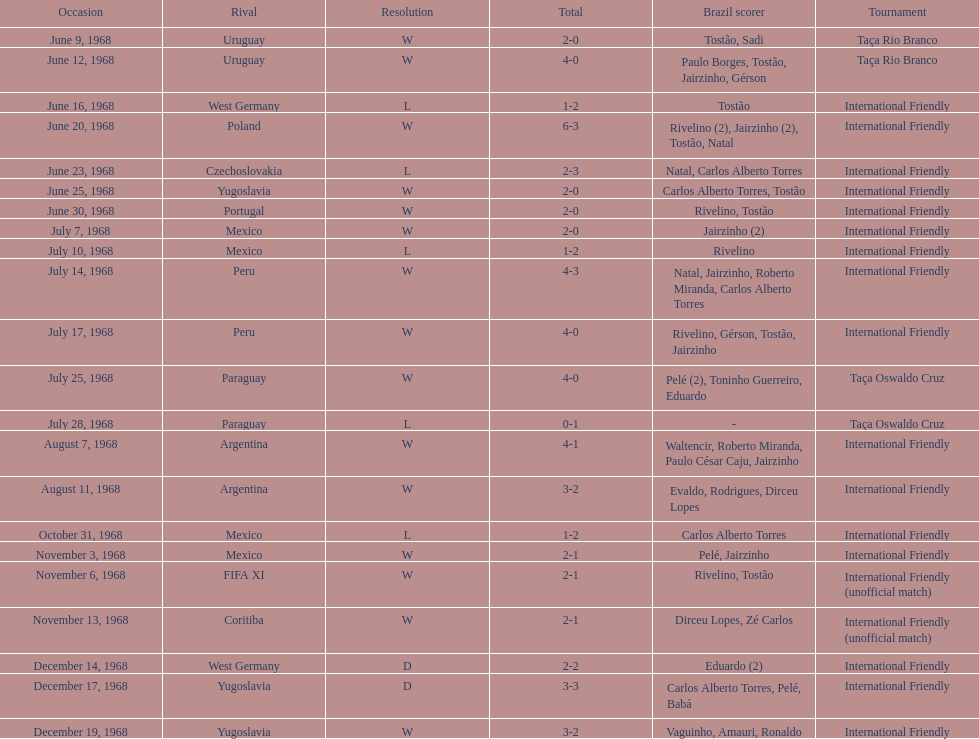How many times did brazil score during the game on november 6th? 2. 